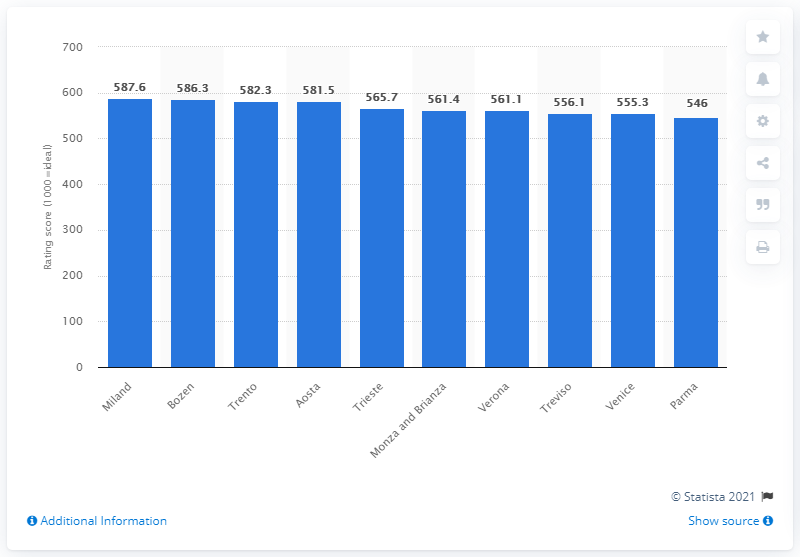Specify some key components in this picture. In the city of Bozen in Trentino--South Tyrol, the second best quality of life was achieved. Trento is the city with the best quality of life in Trentino--South Tyrol. 